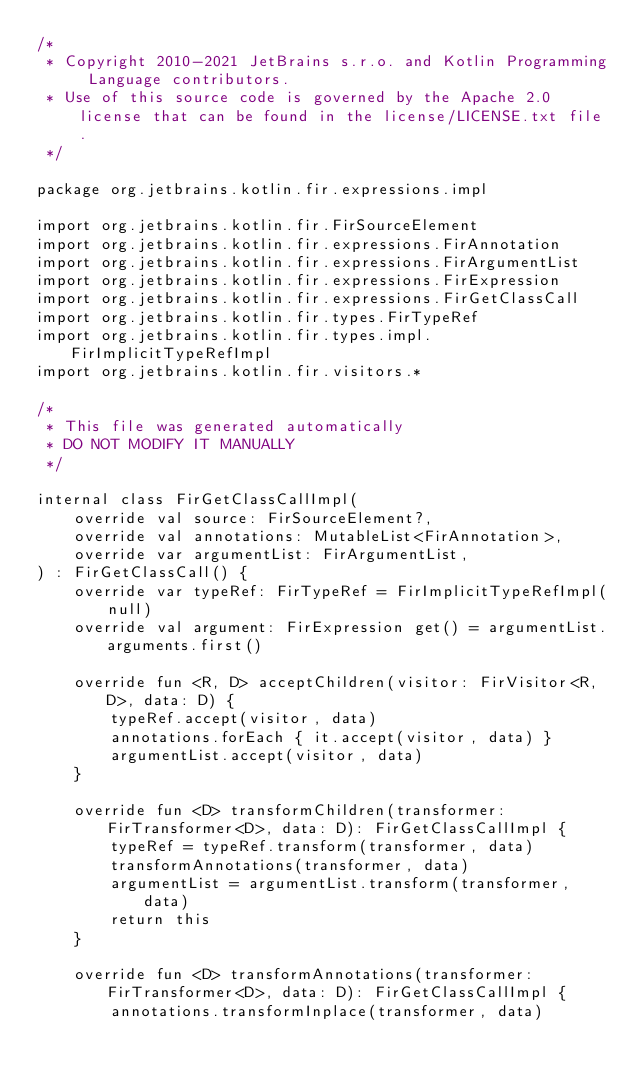Convert code to text. <code><loc_0><loc_0><loc_500><loc_500><_Kotlin_>/*
 * Copyright 2010-2021 JetBrains s.r.o. and Kotlin Programming Language contributors.
 * Use of this source code is governed by the Apache 2.0 license that can be found in the license/LICENSE.txt file.
 */

package org.jetbrains.kotlin.fir.expressions.impl

import org.jetbrains.kotlin.fir.FirSourceElement
import org.jetbrains.kotlin.fir.expressions.FirAnnotation
import org.jetbrains.kotlin.fir.expressions.FirArgumentList
import org.jetbrains.kotlin.fir.expressions.FirExpression
import org.jetbrains.kotlin.fir.expressions.FirGetClassCall
import org.jetbrains.kotlin.fir.types.FirTypeRef
import org.jetbrains.kotlin.fir.types.impl.FirImplicitTypeRefImpl
import org.jetbrains.kotlin.fir.visitors.*

/*
 * This file was generated automatically
 * DO NOT MODIFY IT MANUALLY
 */

internal class FirGetClassCallImpl(
    override val source: FirSourceElement?,
    override val annotations: MutableList<FirAnnotation>,
    override var argumentList: FirArgumentList,
) : FirGetClassCall() {
    override var typeRef: FirTypeRef = FirImplicitTypeRefImpl(null)
    override val argument: FirExpression get() = argumentList.arguments.first()

    override fun <R, D> acceptChildren(visitor: FirVisitor<R, D>, data: D) {
        typeRef.accept(visitor, data)
        annotations.forEach { it.accept(visitor, data) }
        argumentList.accept(visitor, data)
    }

    override fun <D> transformChildren(transformer: FirTransformer<D>, data: D): FirGetClassCallImpl {
        typeRef = typeRef.transform(transformer, data)
        transformAnnotations(transformer, data)
        argumentList = argumentList.transform(transformer, data)
        return this
    }

    override fun <D> transformAnnotations(transformer: FirTransformer<D>, data: D): FirGetClassCallImpl {
        annotations.transformInplace(transformer, data)</code> 